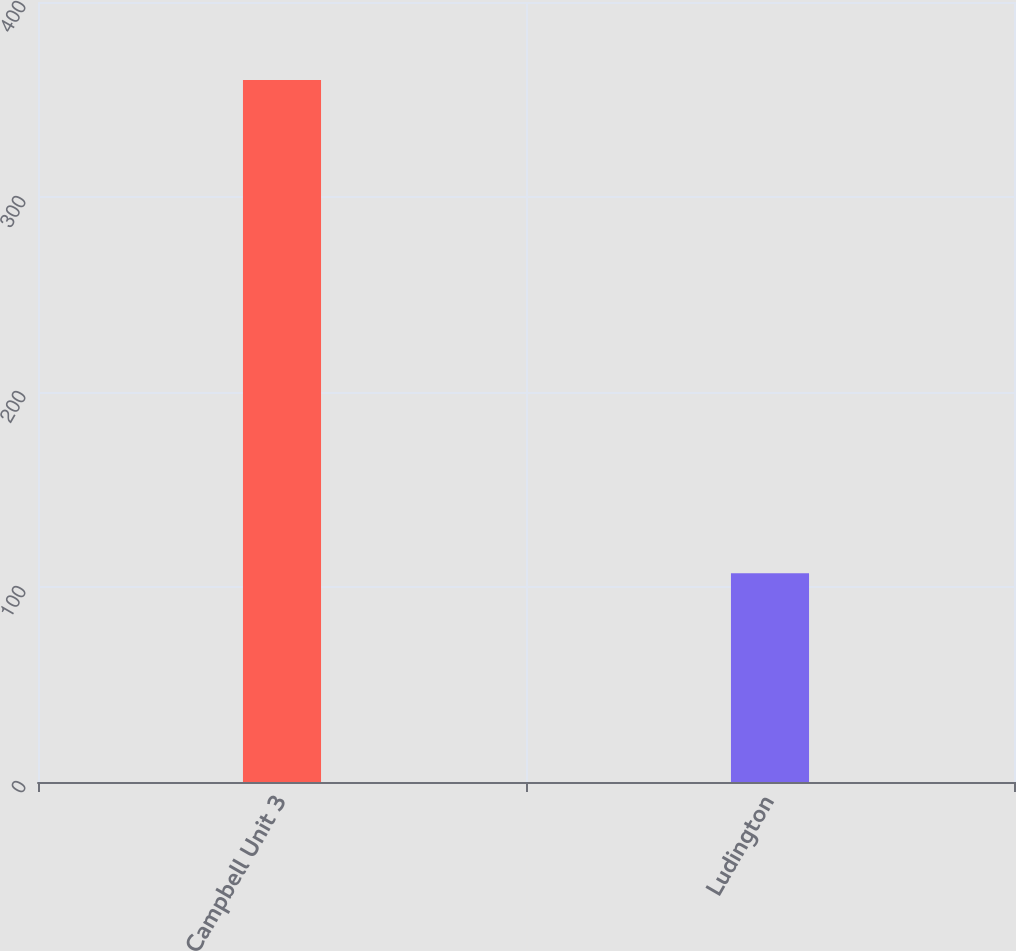Convert chart to OTSL. <chart><loc_0><loc_0><loc_500><loc_500><bar_chart><fcel>Campbell Unit 3<fcel>Ludington<nl><fcel>360<fcel>107<nl></chart> 